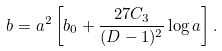Convert formula to latex. <formula><loc_0><loc_0><loc_500><loc_500>b = a ^ { 2 } \left [ b _ { 0 } + \frac { 2 7 C _ { 3 } } { ( D - 1 ) ^ { 2 } } \log a \right ] .</formula> 